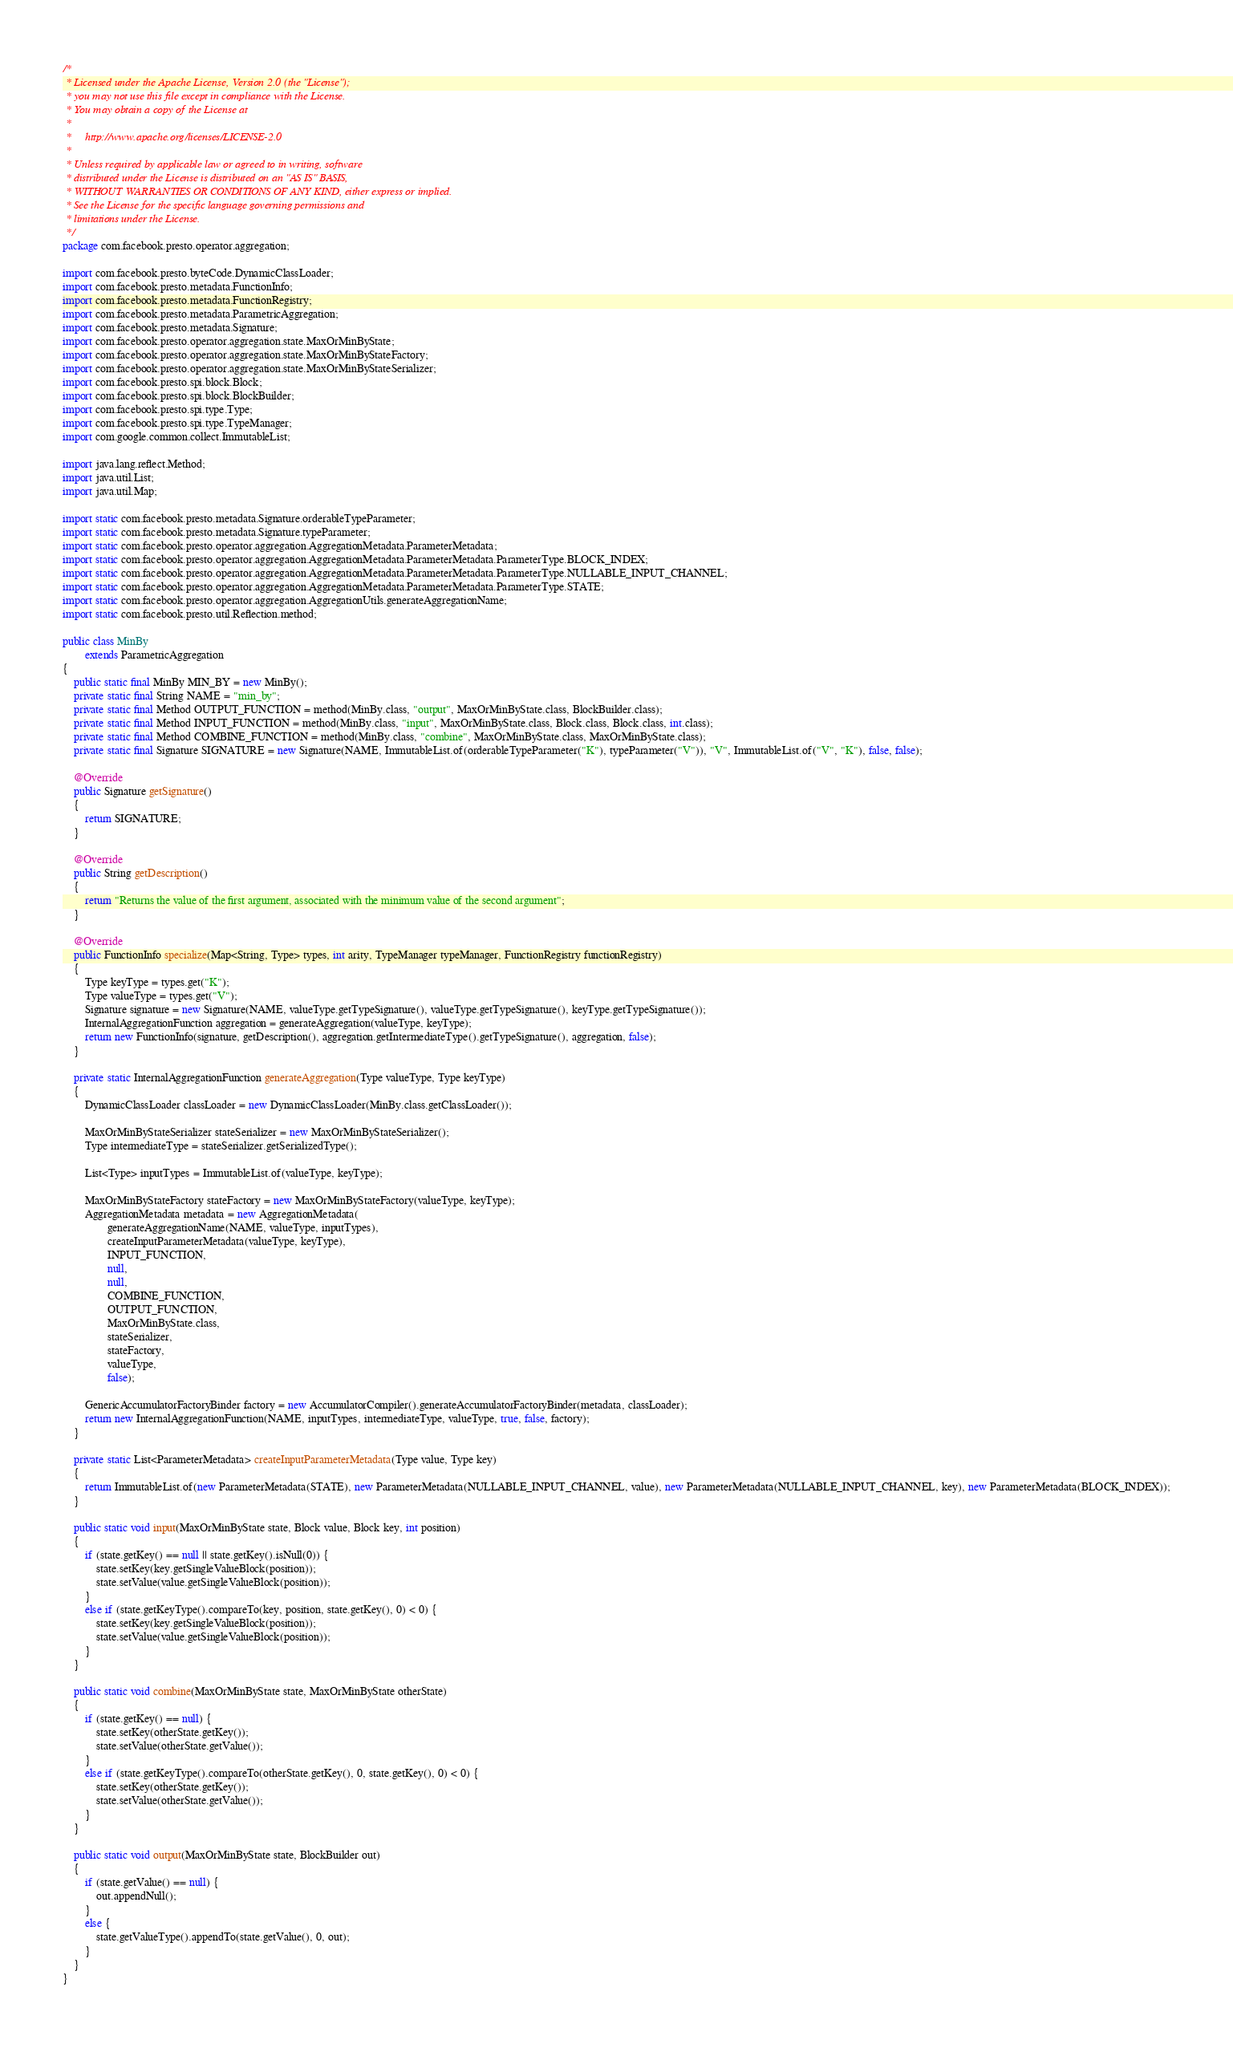Convert code to text. <code><loc_0><loc_0><loc_500><loc_500><_Java_>/*
 * Licensed under the Apache License, Version 2.0 (the "License");
 * you may not use this file except in compliance with the License.
 * You may obtain a copy of the License at
 *
 *     http://www.apache.org/licenses/LICENSE-2.0
 *
 * Unless required by applicable law or agreed to in writing, software
 * distributed under the License is distributed on an "AS IS" BASIS,
 * WITHOUT WARRANTIES OR CONDITIONS OF ANY KIND, either express or implied.
 * See the License for the specific language governing permissions and
 * limitations under the License.
 */
package com.facebook.presto.operator.aggregation;

import com.facebook.presto.byteCode.DynamicClassLoader;
import com.facebook.presto.metadata.FunctionInfo;
import com.facebook.presto.metadata.FunctionRegistry;
import com.facebook.presto.metadata.ParametricAggregation;
import com.facebook.presto.metadata.Signature;
import com.facebook.presto.operator.aggregation.state.MaxOrMinByState;
import com.facebook.presto.operator.aggregation.state.MaxOrMinByStateFactory;
import com.facebook.presto.operator.aggregation.state.MaxOrMinByStateSerializer;
import com.facebook.presto.spi.block.Block;
import com.facebook.presto.spi.block.BlockBuilder;
import com.facebook.presto.spi.type.Type;
import com.facebook.presto.spi.type.TypeManager;
import com.google.common.collect.ImmutableList;

import java.lang.reflect.Method;
import java.util.List;
import java.util.Map;

import static com.facebook.presto.metadata.Signature.orderableTypeParameter;
import static com.facebook.presto.metadata.Signature.typeParameter;
import static com.facebook.presto.operator.aggregation.AggregationMetadata.ParameterMetadata;
import static com.facebook.presto.operator.aggregation.AggregationMetadata.ParameterMetadata.ParameterType.BLOCK_INDEX;
import static com.facebook.presto.operator.aggregation.AggregationMetadata.ParameterMetadata.ParameterType.NULLABLE_INPUT_CHANNEL;
import static com.facebook.presto.operator.aggregation.AggregationMetadata.ParameterMetadata.ParameterType.STATE;
import static com.facebook.presto.operator.aggregation.AggregationUtils.generateAggregationName;
import static com.facebook.presto.util.Reflection.method;

public class MinBy
        extends ParametricAggregation
{
    public static final MinBy MIN_BY = new MinBy();
    private static final String NAME = "min_by";
    private static final Method OUTPUT_FUNCTION = method(MinBy.class, "output", MaxOrMinByState.class, BlockBuilder.class);
    private static final Method INPUT_FUNCTION = method(MinBy.class, "input", MaxOrMinByState.class, Block.class, Block.class, int.class);
    private static final Method COMBINE_FUNCTION = method(MinBy.class, "combine", MaxOrMinByState.class, MaxOrMinByState.class);
    private static final Signature SIGNATURE = new Signature(NAME, ImmutableList.of(orderableTypeParameter("K"), typeParameter("V")), "V", ImmutableList.of("V", "K"), false, false);

    @Override
    public Signature getSignature()
    {
        return SIGNATURE;
    }

    @Override
    public String getDescription()
    {
        return "Returns the value of the first argument, associated with the minimum value of the second argument";
    }

    @Override
    public FunctionInfo specialize(Map<String, Type> types, int arity, TypeManager typeManager, FunctionRegistry functionRegistry)
    {
        Type keyType = types.get("K");
        Type valueType = types.get("V");
        Signature signature = new Signature(NAME, valueType.getTypeSignature(), valueType.getTypeSignature(), keyType.getTypeSignature());
        InternalAggregationFunction aggregation = generateAggregation(valueType, keyType);
        return new FunctionInfo(signature, getDescription(), aggregation.getIntermediateType().getTypeSignature(), aggregation, false);
    }

    private static InternalAggregationFunction generateAggregation(Type valueType, Type keyType)
    {
        DynamicClassLoader classLoader = new DynamicClassLoader(MinBy.class.getClassLoader());

        MaxOrMinByStateSerializer stateSerializer = new MaxOrMinByStateSerializer();
        Type intermediateType = stateSerializer.getSerializedType();

        List<Type> inputTypes = ImmutableList.of(valueType, keyType);

        MaxOrMinByStateFactory stateFactory = new MaxOrMinByStateFactory(valueType, keyType);
        AggregationMetadata metadata = new AggregationMetadata(
                generateAggregationName(NAME, valueType, inputTypes),
                createInputParameterMetadata(valueType, keyType),
                INPUT_FUNCTION,
                null,
                null,
                COMBINE_FUNCTION,
                OUTPUT_FUNCTION,
                MaxOrMinByState.class,
                stateSerializer,
                stateFactory,
                valueType,
                false);

        GenericAccumulatorFactoryBinder factory = new AccumulatorCompiler().generateAccumulatorFactoryBinder(metadata, classLoader);
        return new InternalAggregationFunction(NAME, inputTypes, intermediateType, valueType, true, false, factory);
    }

    private static List<ParameterMetadata> createInputParameterMetadata(Type value, Type key)
    {
        return ImmutableList.of(new ParameterMetadata(STATE), new ParameterMetadata(NULLABLE_INPUT_CHANNEL, value), new ParameterMetadata(NULLABLE_INPUT_CHANNEL, key), new ParameterMetadata(BLOCK_INDEX));
    }

    public static void input(MaxOrMinByState state, Block value, Block key, int position)
    {
        if (state.getKey() == null || state.getKey().isNull(0)) {
            state.setKey(key.getSingleValueBlock(position));
            state.setValue(value.getSingleValueBlock(position));
        }
        else if (state.getKeyType().compareTo(key, position, state.getKey(), 0) < 0) {
            state.setKey(key.getSingleValueBlock(position));
            state.setValue(value.getSingleValueBlock(position));
        }
    }

    public static void combine(MaxOrMinByState state, MaxOrMinByState otherState)
    {
        if (state.getKey() == null) {
            state.setKey(otherState.getKey());
            state.setValue(otherState.getValue());
        }
        else if (state.getKeyType().compareTo(otherState.getKey(), 0, state.getKey(), 0) < 0) {
            state.setKey(otherState.getKey());
            state.setValue(otherState.getValue());
        }
    }

    public static void output(MaxOrMinByState state, BlockBuilder out)
    {
        if (state.getValue() == null) {
            out.appendNull();
        }
        else {
            state.getValueType().appendTo(state.getValue(), 0, out);
        }
    }
}
</code> 